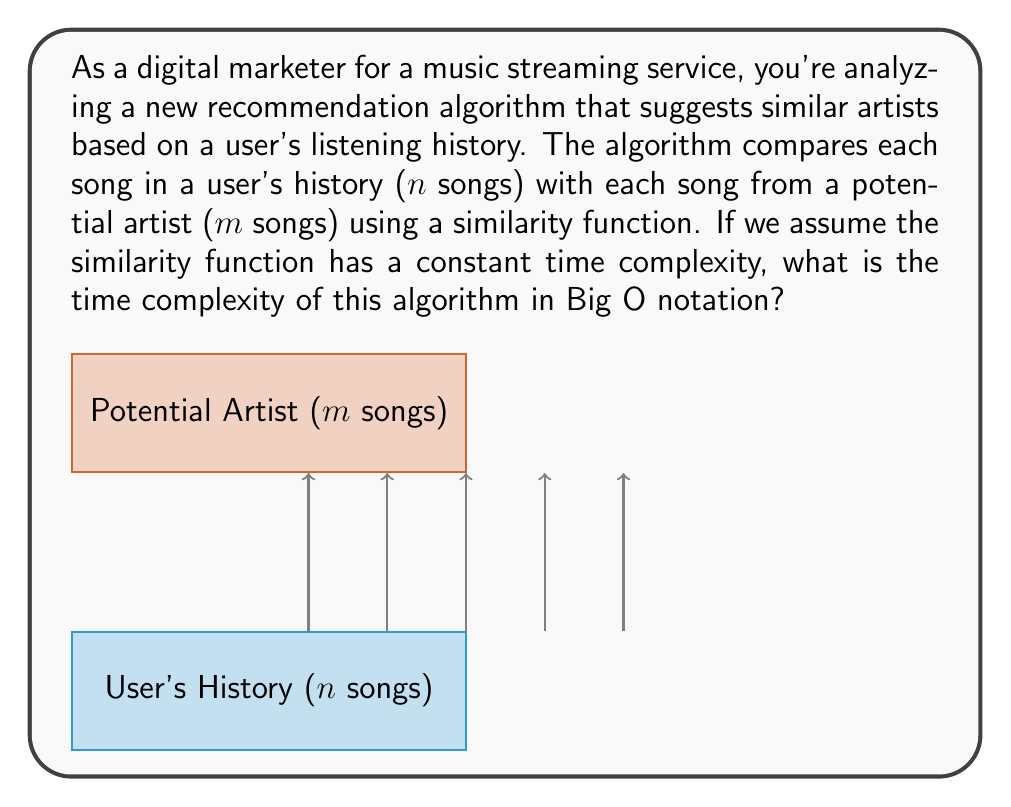Give your solution to this math problem. Let's break down the problem step-by-step:

1) The algorithm compares each song in the user's history with each song from the potential artist.

2) We have:
   - $n$ songs in the user's history
   - $m$ songs from the potential artist

3) For each song in the user's history, the algorithm needs to compare it with all songs from the potential artist. This forms a nested loop structure:

   ```
   for each song in user's history (n times):
       for each song from potential artist (m times):
           compare songs (constant time)
   ```

4) The inner loop runs $m$ times for each iteration of the outer loop.

5) The outer loop runs $n$ times.

6) Therefore, the total number of comparisons is $n * m$.

7) Since the similarity function has a constant time complexity, let's call it $c$.

8) The total time complexity is then $O(n * m * c)$.

9) In Big O notation, we drop constant factors, so we can simplify this to $O(nm)$.

This quadratic time complexity $O(nm)$ is typical for algorithms that compare every element of one set with every element of another set.
Answer: $O(nm)$ 